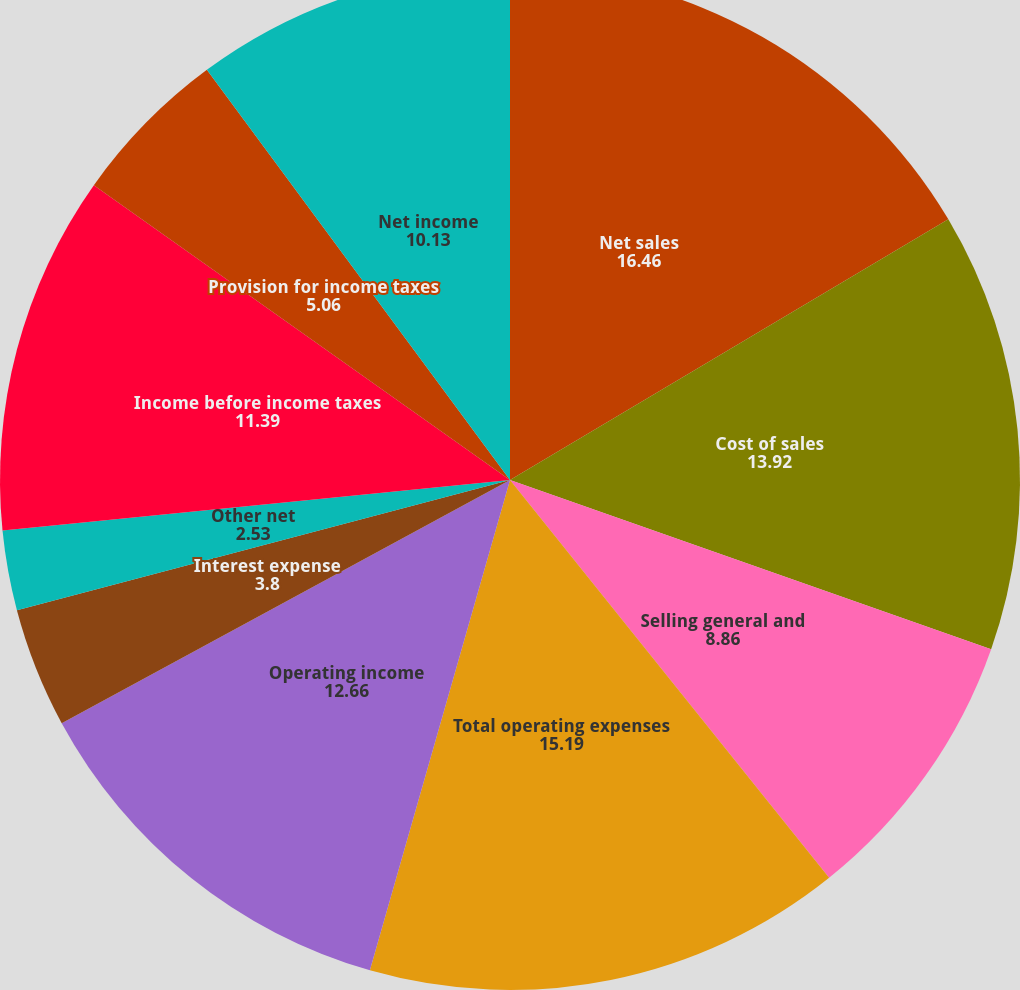Convert chart. <chart><loc_0><loc_0><loc_500><loc_500><pie_chart><fcel>Net sales<fcel>Cost of sales<fcel>Selling general and<fcel>Total operating expenses<fcel>Operating income<fcel>Interest expense<fcel>Other net<fcel>Income before income taxes<fcel>Provision for income taxes<fcel>Net income<nl><fcel>16.46%<fcel>13.92%<fcel>8.86%<fcel>15.19%<fcel>12.66%<fcel>3.8%<fcel>2.53%<fcel>11.39%<fcel>5.06%<fcel>10.13%<nl></chart> 